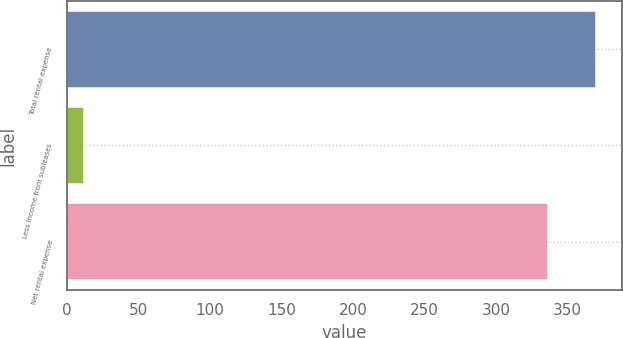<chart> <loc_0><loc_0><loc_500><loc_500><bar_chart><fcel>Total rental expense<fcel>Less Income from subleases<fcel>Net rental expense<nl><fcel>369.6<fcel>12<fcel>336<nl></chart> 